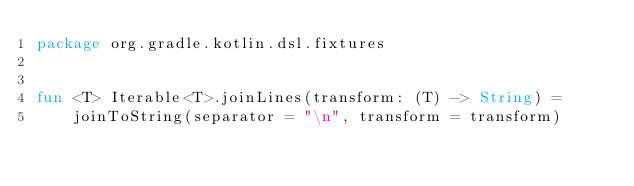<code> <loc_0><loc_0><loc_500><loc_500><_Kotlin_>package org.gradle.kotlin.dsl.fixtures


fun <T> Iterable<T>.joinLines(transform: (T) -> String) =
    joinToString(separator = "\n", transform = transform)
</code> 